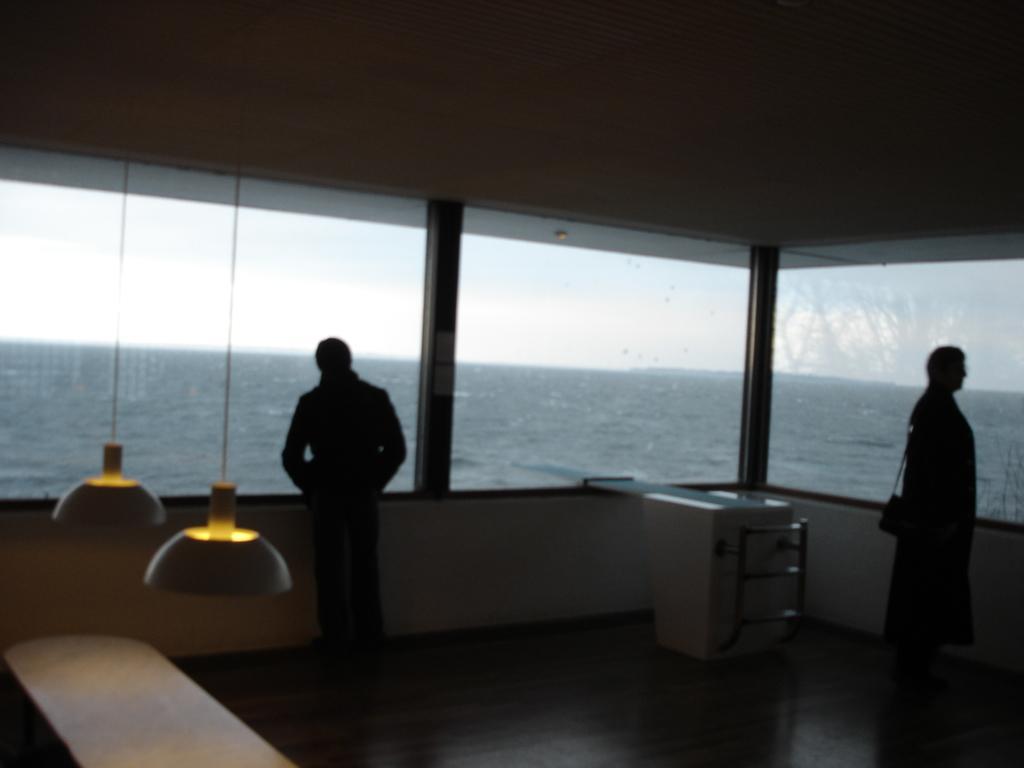Can you describe this image briefly? In the center of the image there is a wall, glass, lights, tables, two persons are standing and a few other objects. Through glass, we can see the sky and water, 